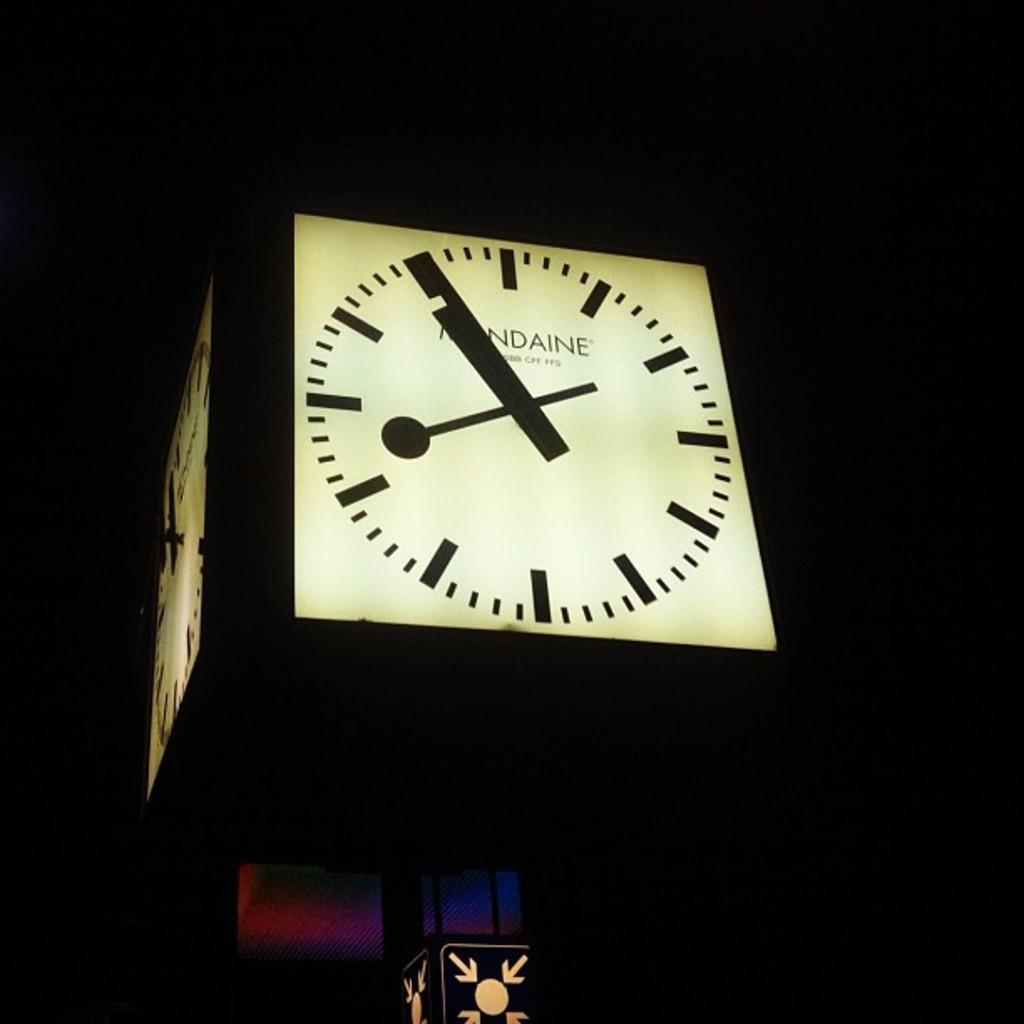<image>
Share a concise interpretation of the image provided. A large clock with the word Mundaine near the top center. 